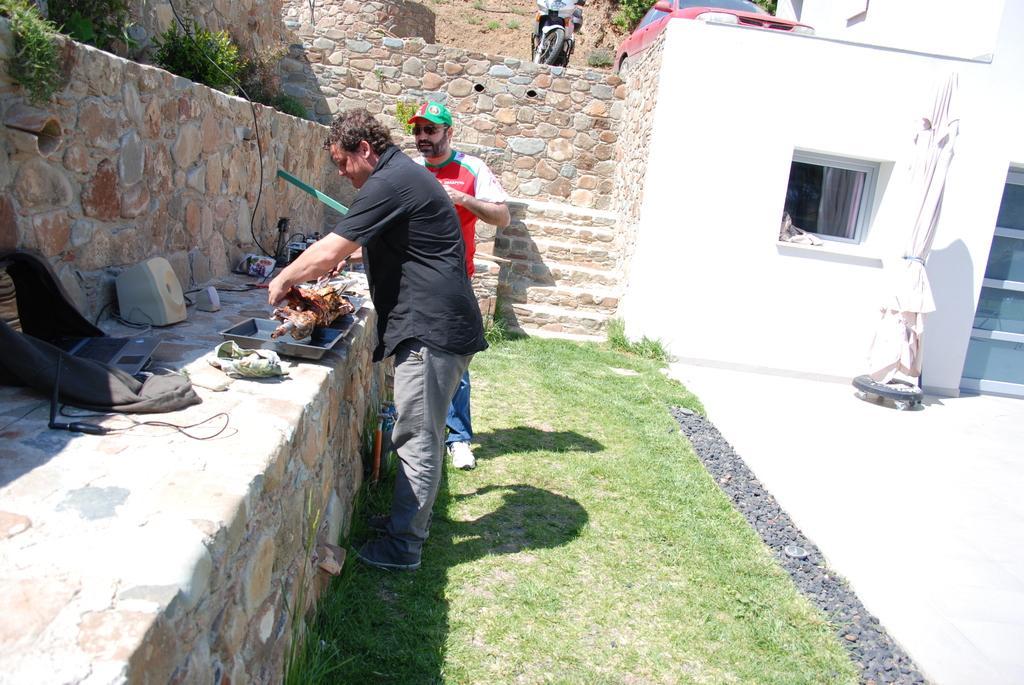Could you give a brief overview of what you see in this image? This picture shows couple of men standing and a man wore a cap on his head and we see a building and few plants and we see a car and a motorcycle parked and we see a bag and grass on the ground. 